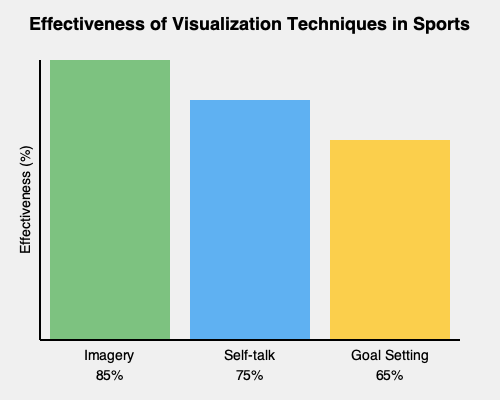Based on the comparison diagram of visualization techniques in sports, which technique appears to be the most effective, and by what percentage does it surpass the least effective technique shown? To answer this question, we need to follow these steps:

1. Identify the visualization techniques shown in the diagram:
   - Imagery
   - Self-talk
   - Goal Setting

2. Determine the effectiveness percentages for each technique:
   - Imagery: 85%
   - Self-talk: 75%
   - Goal Setting: 65%

3. Identify the most effective technique:
   Imagery has the highest percentage at 85%, making it the most effective technique.

4. Identify the least effective technique:
   Goal Setting has the lowest percentage at 65%, making it the least effective technique.

5. Calculate the difference between the most and least effective techniques:
   $85\% - 65\% = 20\%$

Therefore, Imagery is the most effective technique, surpassing Goal Setting (the least effective technique) by 20%.
Answer: Imagery; 20% 